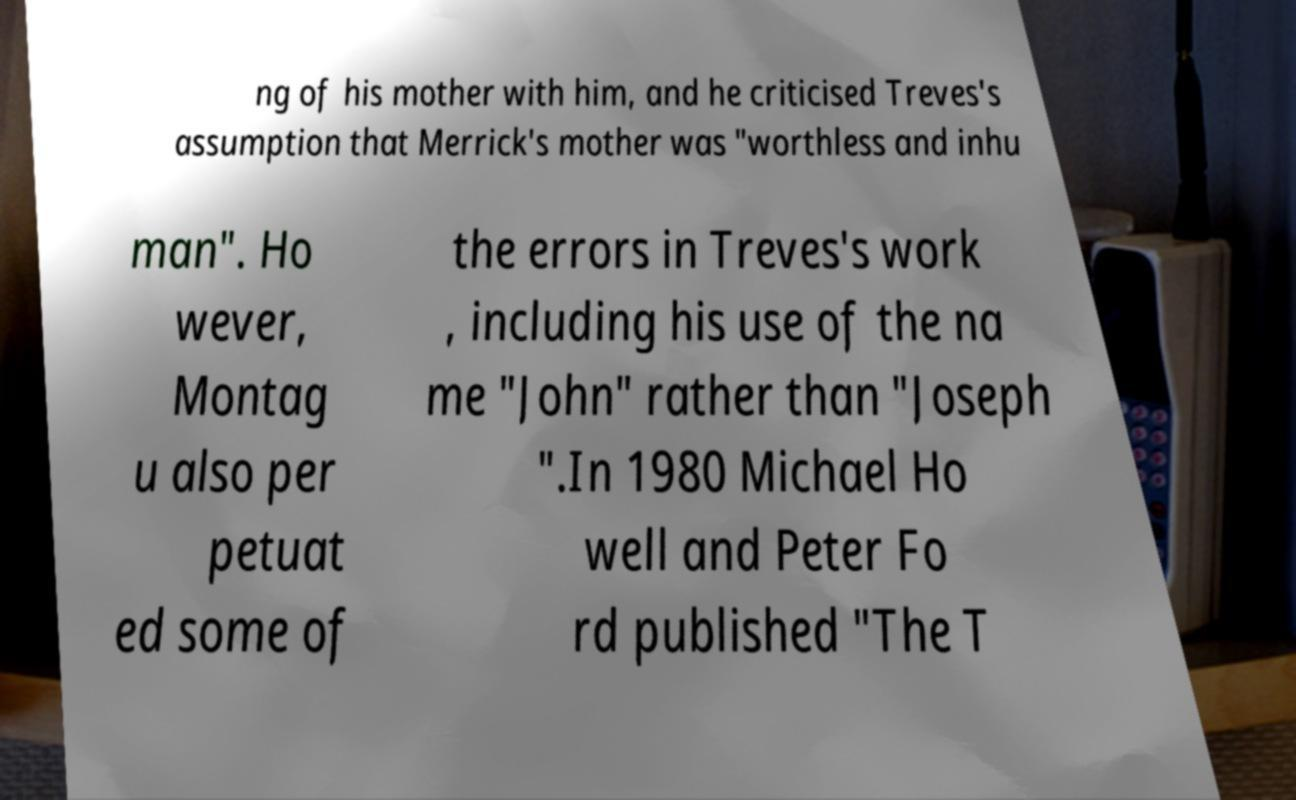Please identify and transcribe the text found in this image. ng of his mother with him, and he criticised Treves's assumption that Merrick's mother was "worthless and inhu man". Ho wever, Montag u also per petuat ed some of the errors in Treves's work , including his use of the na me "John" rather than "Joseph ".In 1980 Michael Ho well and Peter Fo rd published "The T 